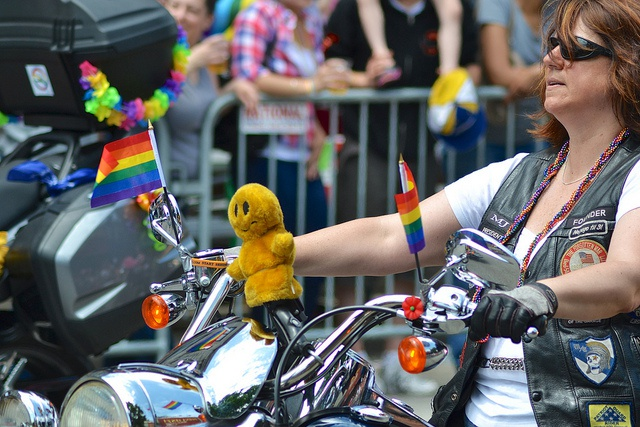Describe the objects in this image and their specific colors. I can see people in black, gray, and white tones, motorcycle in black, gray, white, and darkgray tones, people in black, darkgray, and gray tones, people in black, darkgray, lightpink, brown, and violet tones, and people in black, gray, and tan tones in this image. 